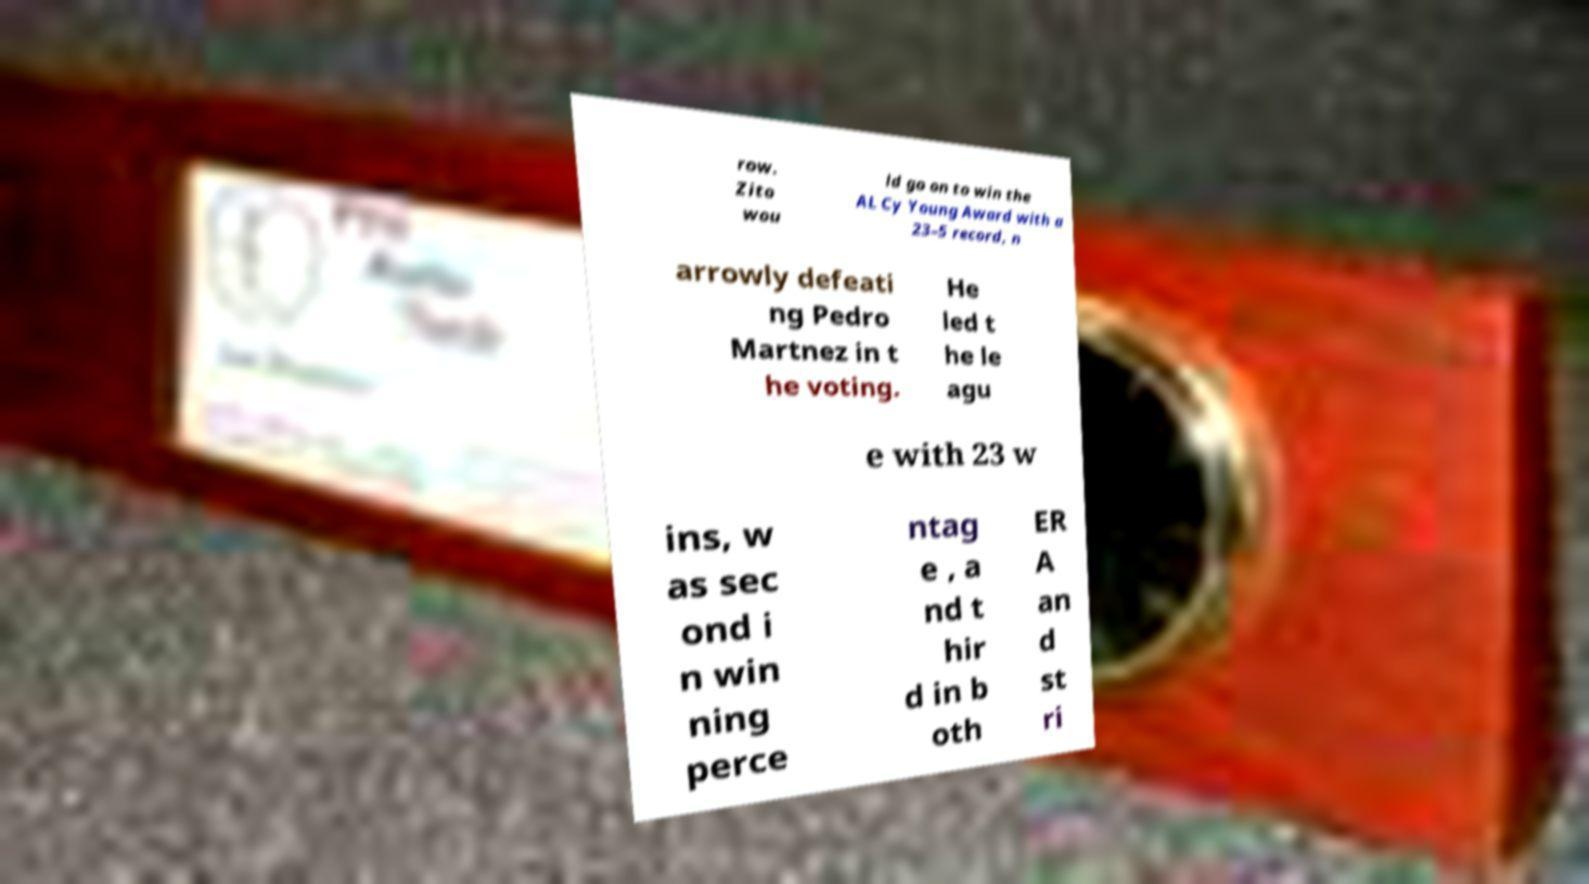Please read and relay the text visible in this image. What does it say? row. Zito wou ld go on to win the AL Cy Young Award with a 23–5 record, n arrowly defeati ng Pedro Martnez in t he voting. He led t he le agu e with 23 w ins, w as sec ond i n win ning perce ntag e , a nd t hir d in b oth ER A an d st ri 